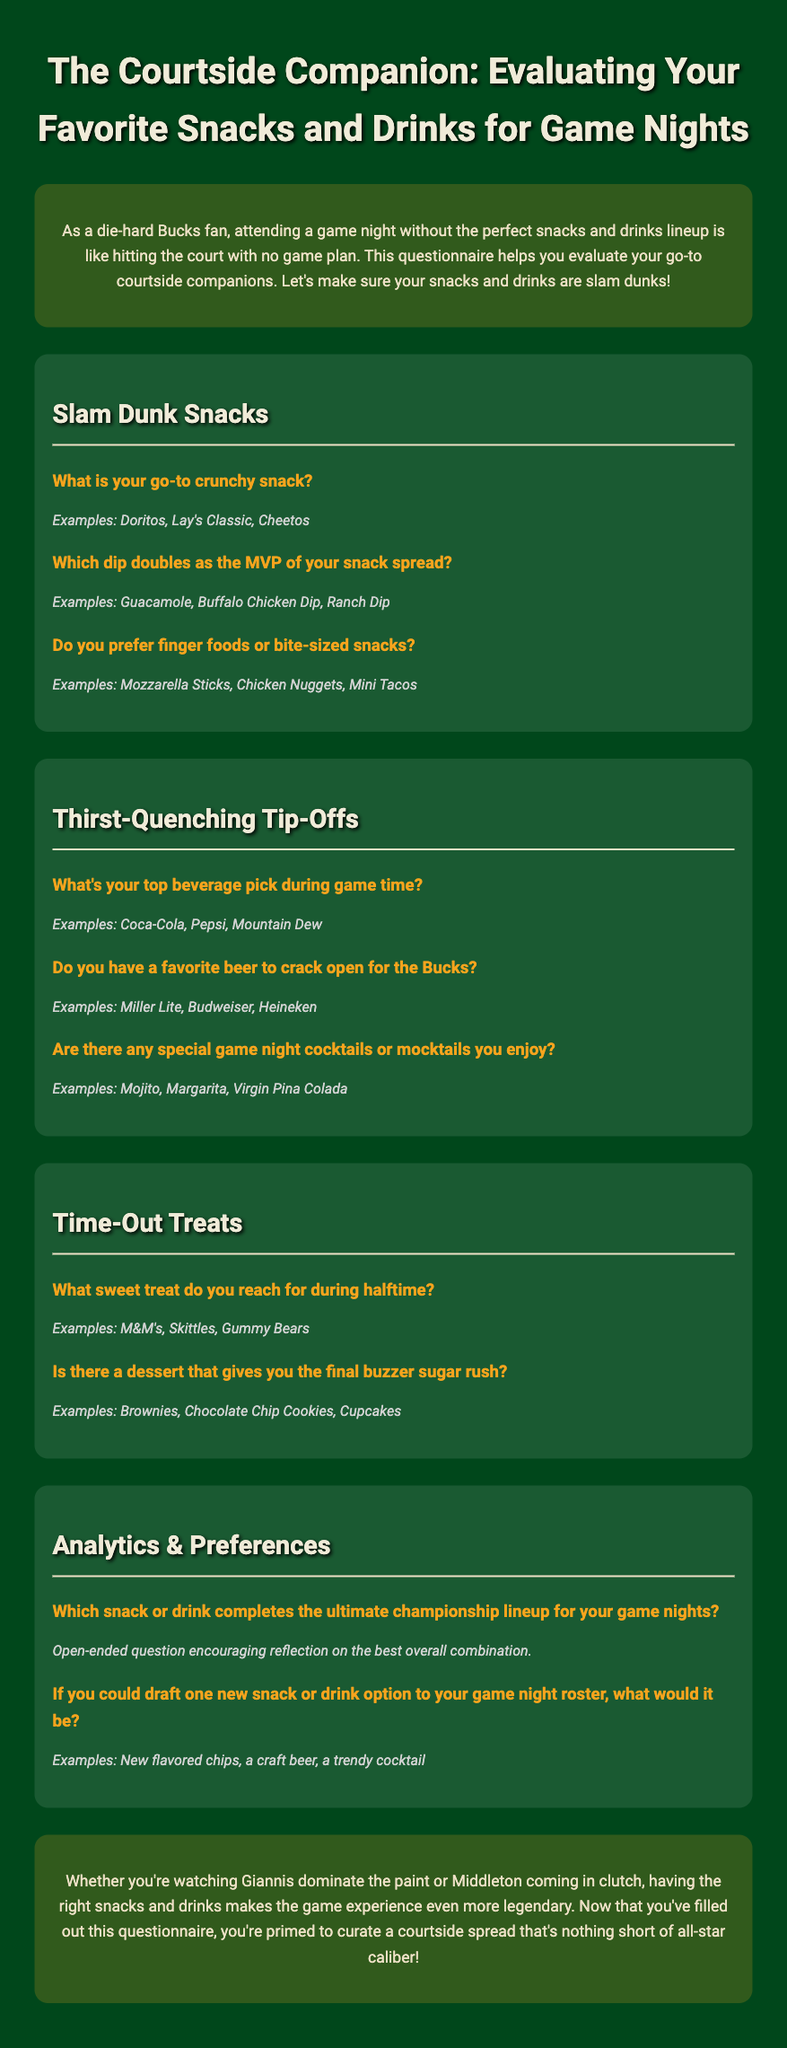What is the main purpose of the questionnaire? The questionnaire aims to help evaluate go-to snacks and drinks for game nights as a Bucks fan.
Answer: Evaluate snacks and drinks What is the header color of the sections? The section headers are styled with a specific color in the document; this refers to the color used in headings.
Answer: #F7A41D What snacks are categorized as "Slam Dunk Snacks"? The section discusses specific snack types that fans prefer, specifically those that are crunchy or fun to eat during games.
Answer: Crunchy snacks What beverages are preferred during game time? The document mentions the top beverage picks, outlining popular choices for fans during games.
Answer: Coca-Cola, Pepsi, Mountain Dew Which dessert is mentioned for a halftime sweet treat? The document lists options for sweet treats enjoyed during halftime, focusing on candies and confections.
Answer: M&M's What question encourages reflection on the best overall snack and drink combination? This question is designed for participants to think about their ultimate game night favorites.
Answer: Which snack or drink completes the ultimate championship lineup for your game nights? What does the conclusion emphasize regarding the game night experience? The conclusion sums up the importance of selecting the right snacks and drinks for a memorable experience.
Answer: Snacks and drinks make the game experience legendary Which dip is noted as a snack spread MVP? The document provides examples of dips that are popular choices among fans.
Answer: Guacamole, Buffalo Chicken Dip, Ranch Dip 